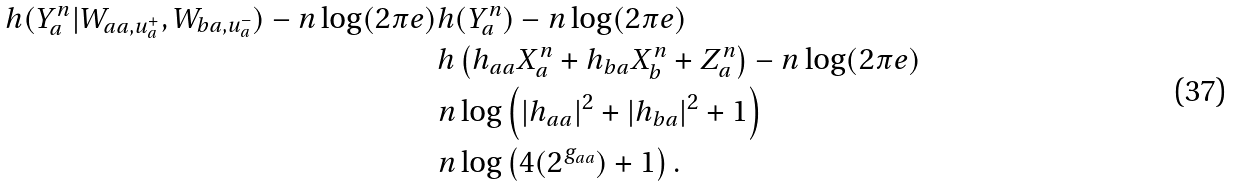<formula> <loc_0><loc_0><loc_500><loc_500>h ( Y _ { a } ^ { n } | W _ { a a , u _ { a } ^ { + } } , W _ { b a , u _ { a } ^ { - } } ) - n \log ( 2 \pi e ) & h ( Y _ { a } ^ { n } ) - n \log ( 2 \pi e ) \\ & h \left ( h _ { a a } X _ { a } ^ { n } + h _ { b a } X _ { b } ^ { n } + Z _ { a } ^ { n } \right ) - n \log ( 2 \pi e ) \\ & n \log \left ( | h _ { a a } | ^ { 2 } + | h _ { b a } | ^ { 2 } + 1 \right ) \\ & n \log \left ( 4 ( 2 ^ { g _ { a a } } ) + 1 \right ) .</formula> 